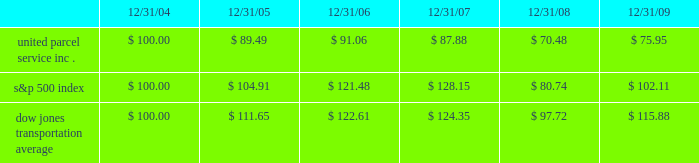( 1 ) includes shares repurchased through our publicly announced share repurchase program and shares tendered to pay the exercise price and tax withholding on employee stock options .
Shareowner return performance graph the following performance graph and related information shall not be deemed 201csoliciting material 201d or to be 201cfiled 201d with the securities and exchange commission , nor shall such information be incorporated by reference into any future filing under the securities act of 1933 or securities exchange act of 1934 , each as amended , except to the extent that the company specifically incorporates such information by reference into such filing .
The following graph shows a five-year comparison of cumulative total shareowners 2019 returns for our class b common stock , the s&p 500 index , and the dow jones transportation average .
The comparison of the total cumulative return on investment , which is the change in the quarterly stock price plus reinvested dividends for each of the quarterly periods , assumes that $ 100 was invested on december 31 , 2004 in the s&p 500 index , the dow jones transportation average , and our class b common stock .
Comparison of five year cumulative total return $ 40.00 $ 60.00 $ 80.00 $ 100.00 $ 120.00 $ 140.00 $ 160.00 2004 20092008200720062005 s&p 500 ups dj transport .

What was the difference in percentage cumulative return on investment for united parcel service inc . compared to the s&p 500 index for the five year period ended 12/31/09? 
Computations: (((75.95 - 100) / 100) - ((102.11 - 100) / 100))
Answer: -0.2616. 